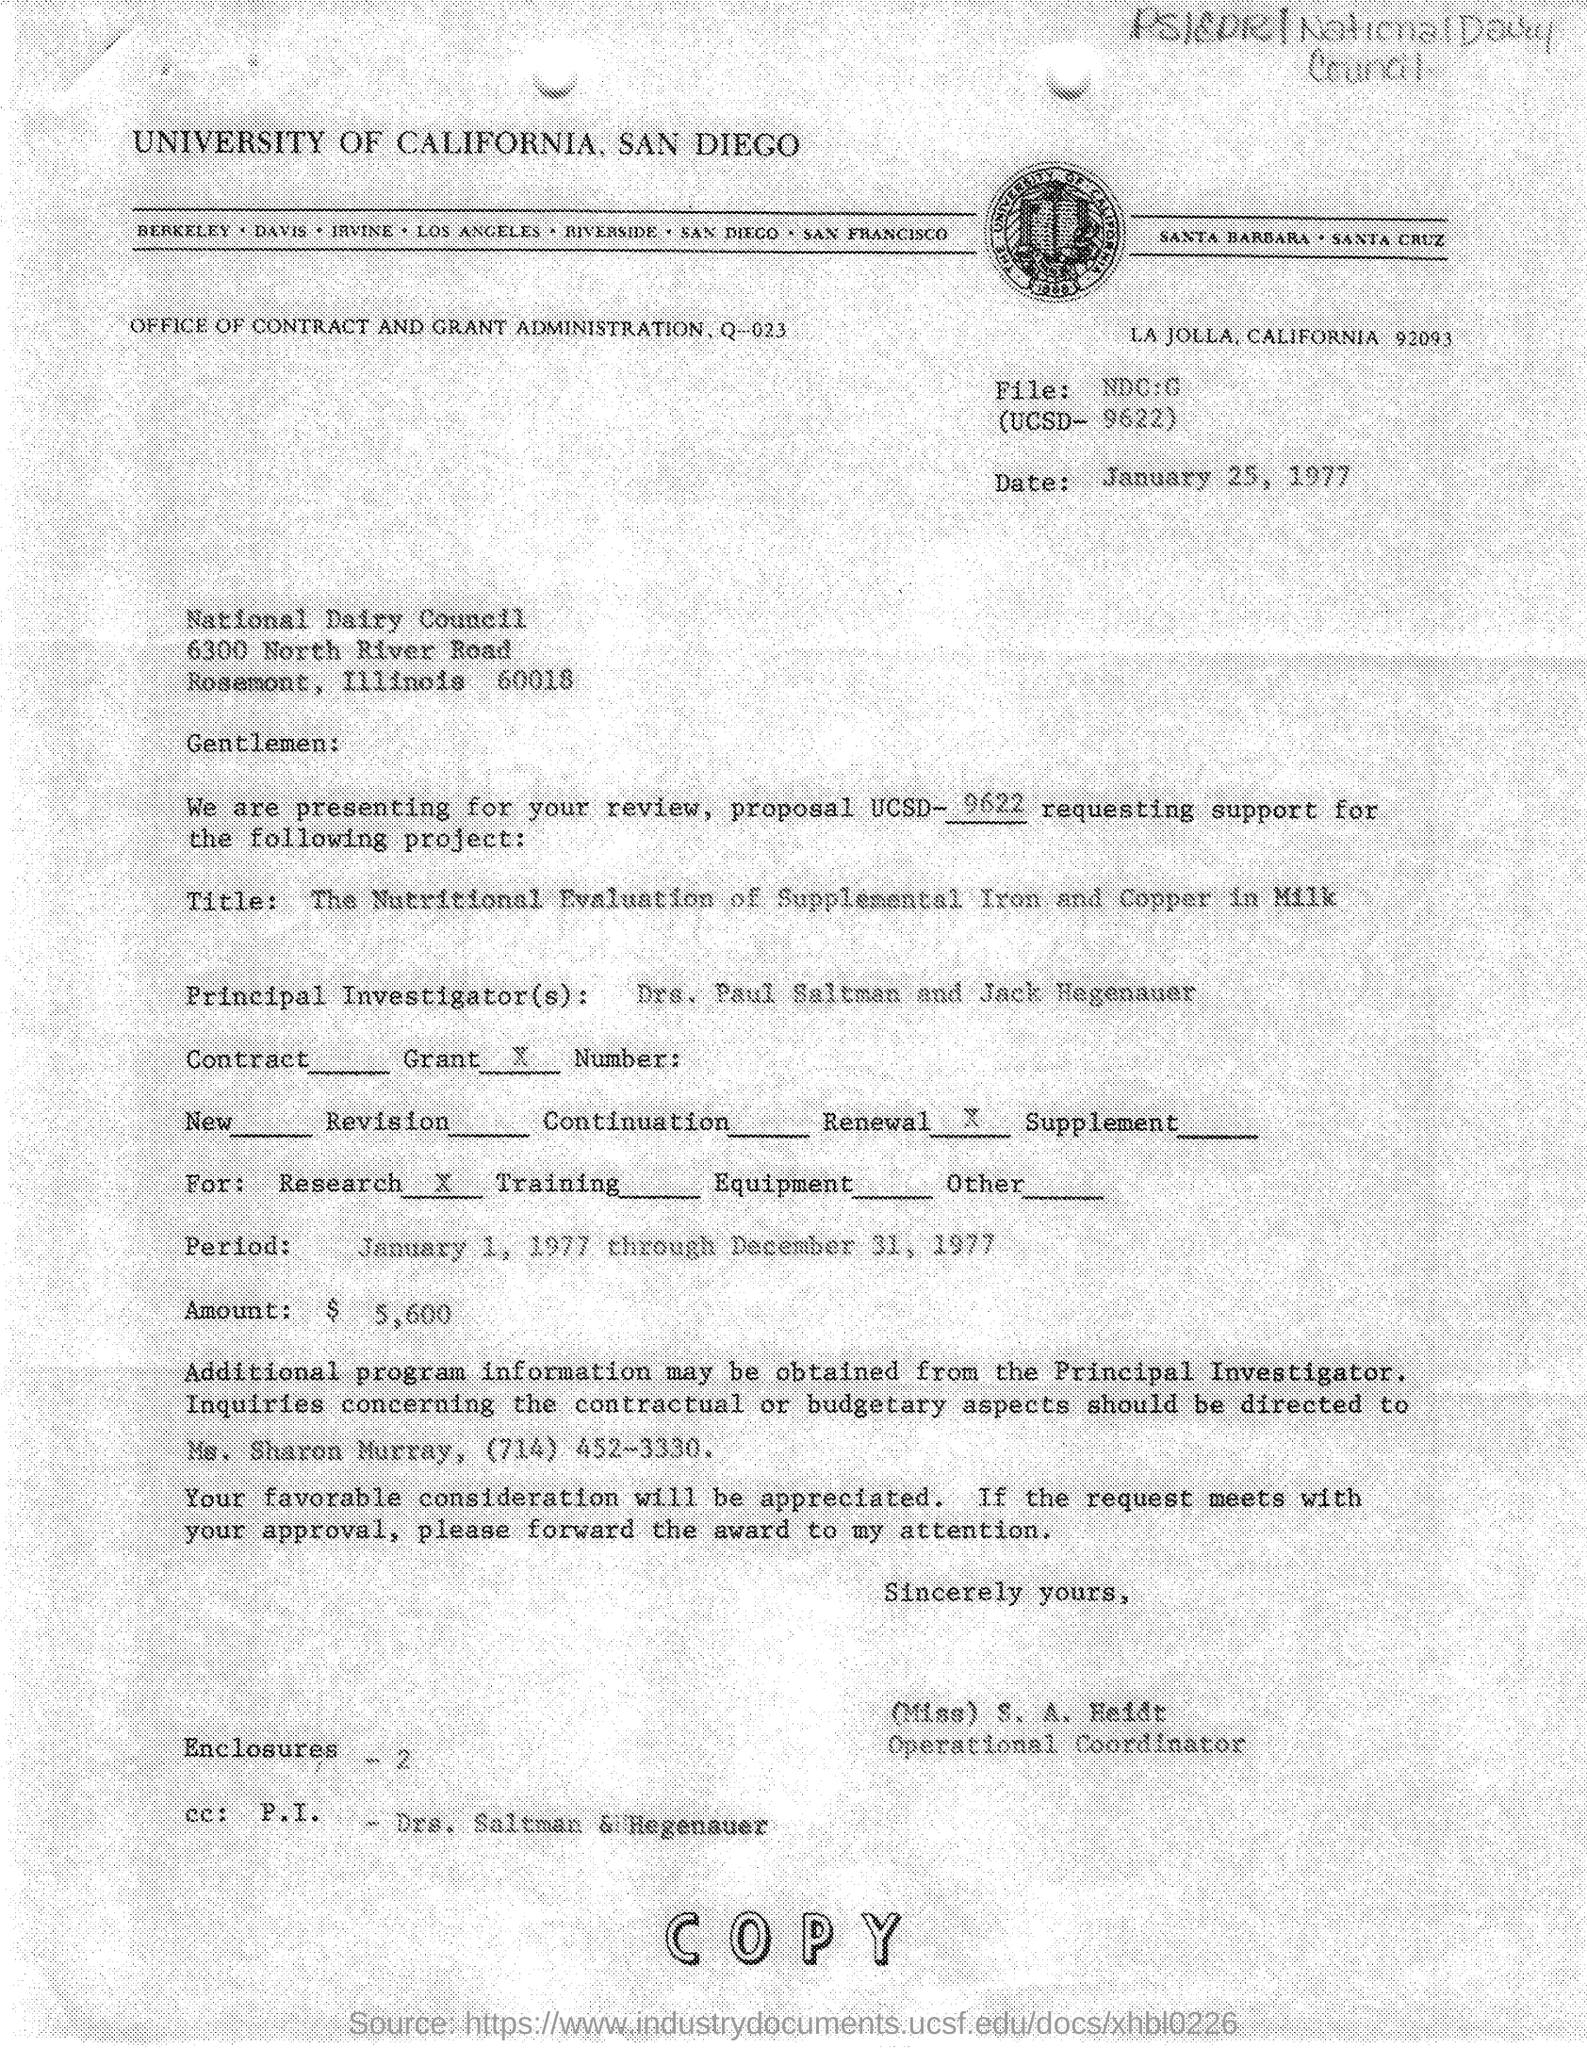Draw attention to some important aspects in this diagram. The date mentioned in the given page is January 25, 1977. The university mentioned in the given letter is the University of California. The letter mentions an amount of $5,600. The UCSD number mentioned in the given letter is 9622. The National Dairy Council is the name of the council mentioned in the given letter. 